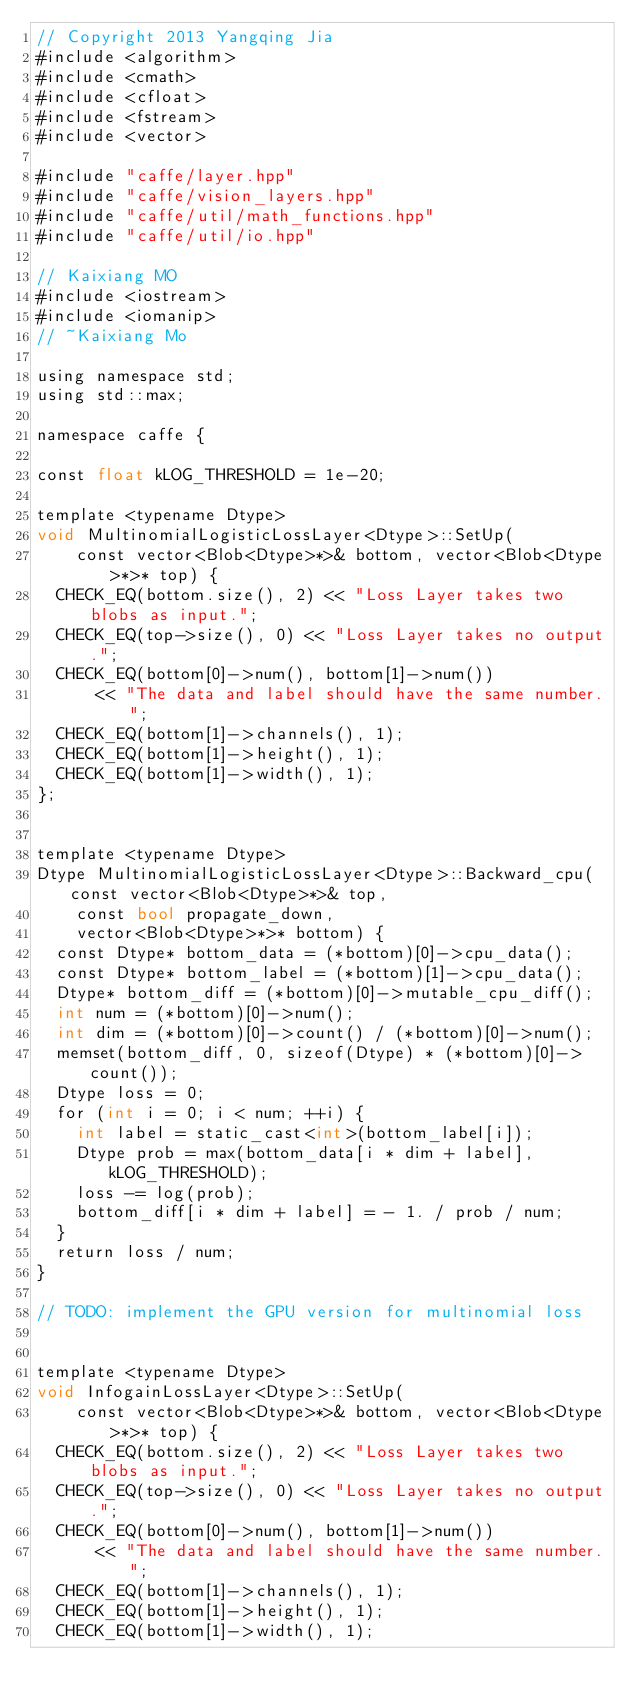<code> <loc_0><loc_0><loc_500><loc_500><_Cuda_>// Copyright 2013 Yangqing Jia
#include <algorithm>
#include <cmath>
#include <cfloat>
#include <fstream>
#include <vector>

#include "caffe/layer.hpp"
#include "caffe/vision_layers.hpp"
#include "caffe/util/math_functions.hpp"
#include "caffe/util/io.hpp"

// Kaixiang MO
#include <iostream>
#include <iomanip>
// ~Kaixiang Mo

using namespace std;
using std::max;

namespace caffe {

const float kLOG_THRESHOLD = 1e-20;

template <typename Dtype>
void MultinomialLogisticLossLayer<Dtype>::SetUp(
		const vector<Blob<Dtype>*>& bottom, vector<Blob<Dtype>*>* top) {
	CHECK_EQ(bottom.size(), 2) << "Loss Layer takes two blobs as input.";
	CHECK_EQ(top->size(), 0) << "Loss Layer takes no output.";
	CHECK_EQ(bottom[0]->num(), bottom[1]->num())
			<< "The data and label should have the same number.";
	CHECK_EQ(bottom[1]->channels(), 1);
	CHECK_EQ(bottom[1]->height(), 1);
	CHECK_EQ(bottom[1]->width(), 1);
};


template <typename Dtype>
Dtype MultinomialLogisticLossLayer<Dtype>::Backward_cpu(const vector<Blob<Dtype>*>& top,
		const bool propagate_down,
		vector<Blob<Dtype>*>* bottom) {
	const Dtype* bottom_data = (*bottom)[0]->cpu_data();
	const Dtype* bottom_label = (*bottom)[1]->cpu_data();
	Dtype* bottom_diff = (*bottom)[0]->mutable_cpu_diff();
	int num = (*bottom)[0]->num();
	int dim = (*bottom)[0]->count() / (*bottom)[0]->num();
	memset(bottom_diff, 0, sizeof(Dtype) * (*bottom)[0]->count());
	Dtype loss = 0;
	for (int i = 0; i < num; ++i) {
		int label = static_cast<int>(bottom_label[i]);
		Dtype prob = max(bottom_data[i * dim + label], kLOG_THRESHOLD);
		loss -= log(prob);
		bottom_diff[i * dim + label] = - 1. / prob / num;
	}
	return loss / num;
}

// TODO: implement the GPU version for multinomial loss


template <typename Dtype>
void InfogainLossLayer<Dtype>::SetUp(
		const vector<Blob<Dtype>*>& bottom, vector<Blob<Dtype>*>* top) {
	CHECK_EQ(bottom.size(), 2) << "Loss Layer takes two blobs as input.";
	CHECK_EQ(top->size(), 0) << "Loss Layer takes no output.";
	CHECK_EQ(bottom[0]->num(), bottom[1]->num())
			<< "The data and label should have the same number.";
	CHECK_EQ(bottom[1]->channels(), 1);
	CHECK_EQ(bottom[1]->height(), 1);
	CHECK_EQ(bottom[1]->width(), 1);</code> 